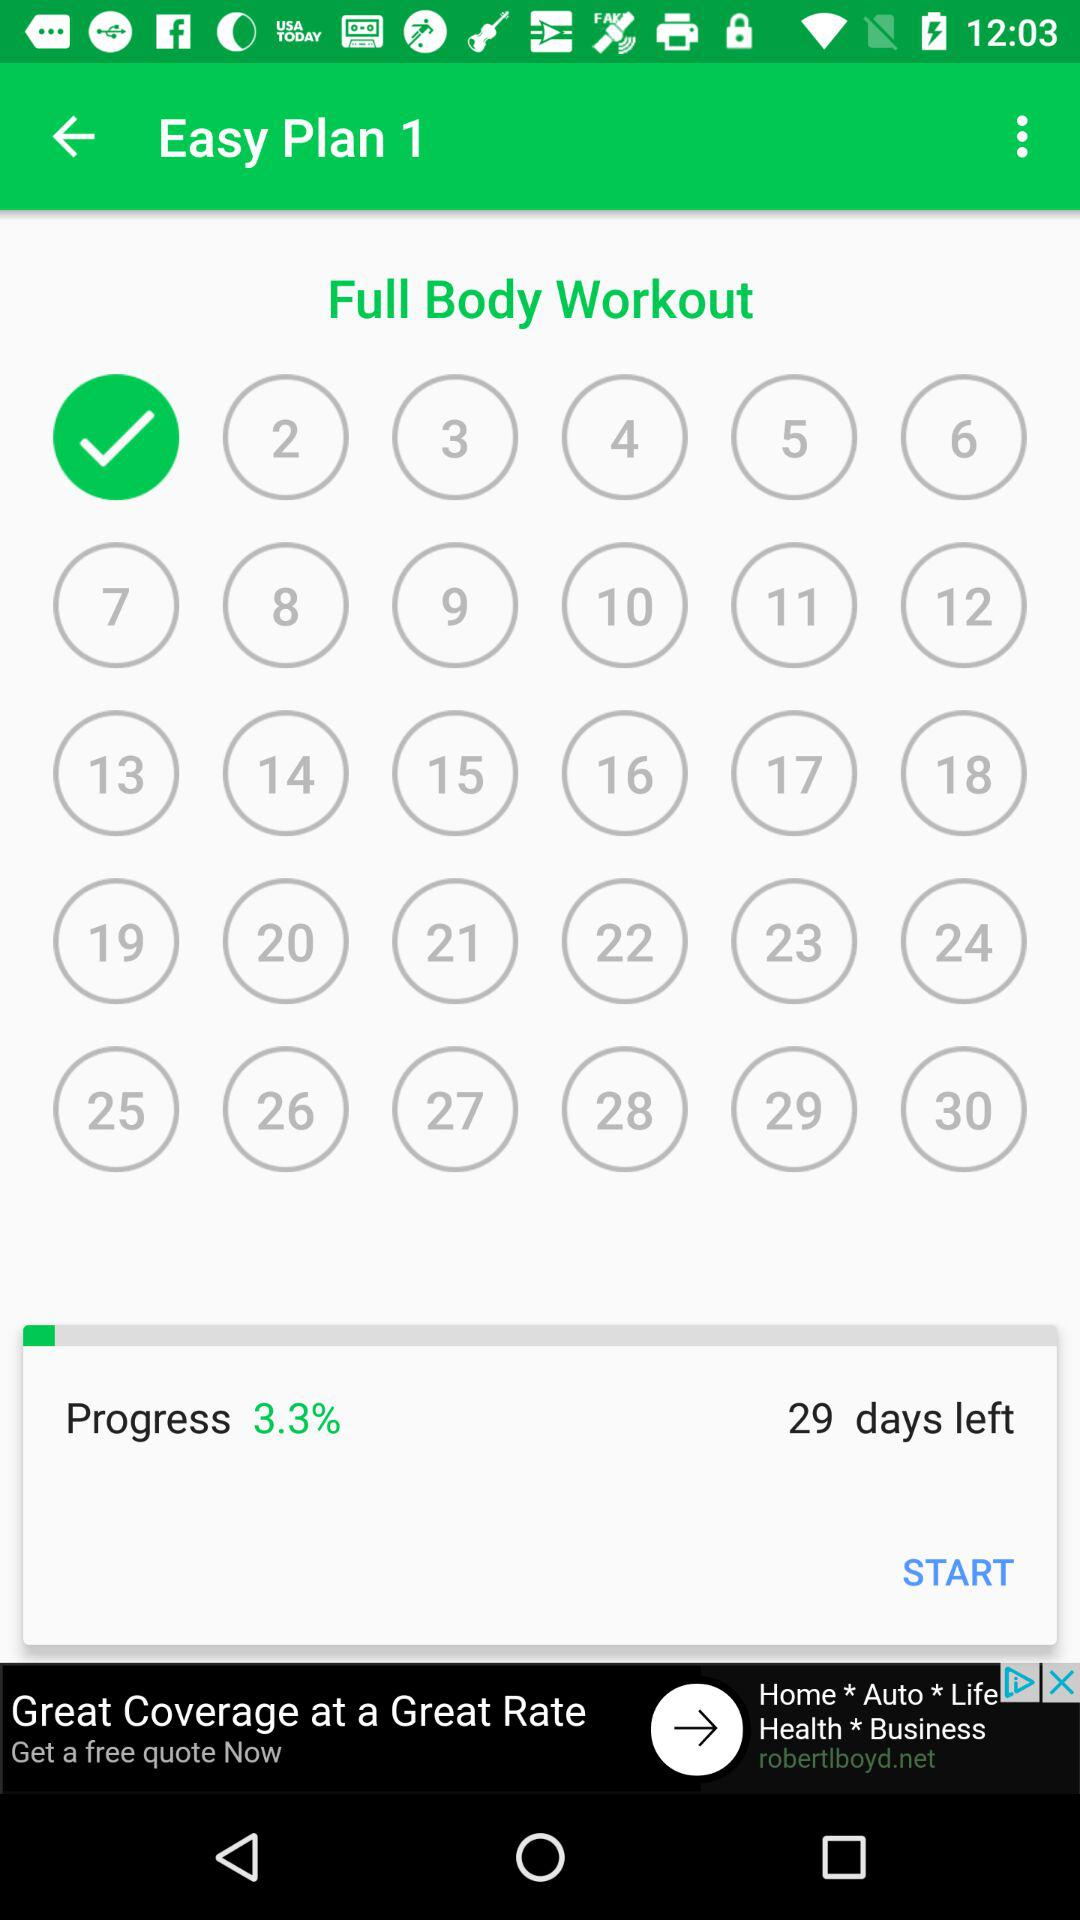What is the selected day?
When the provided information is insufficient, respond with <no answer>. <no answer> 